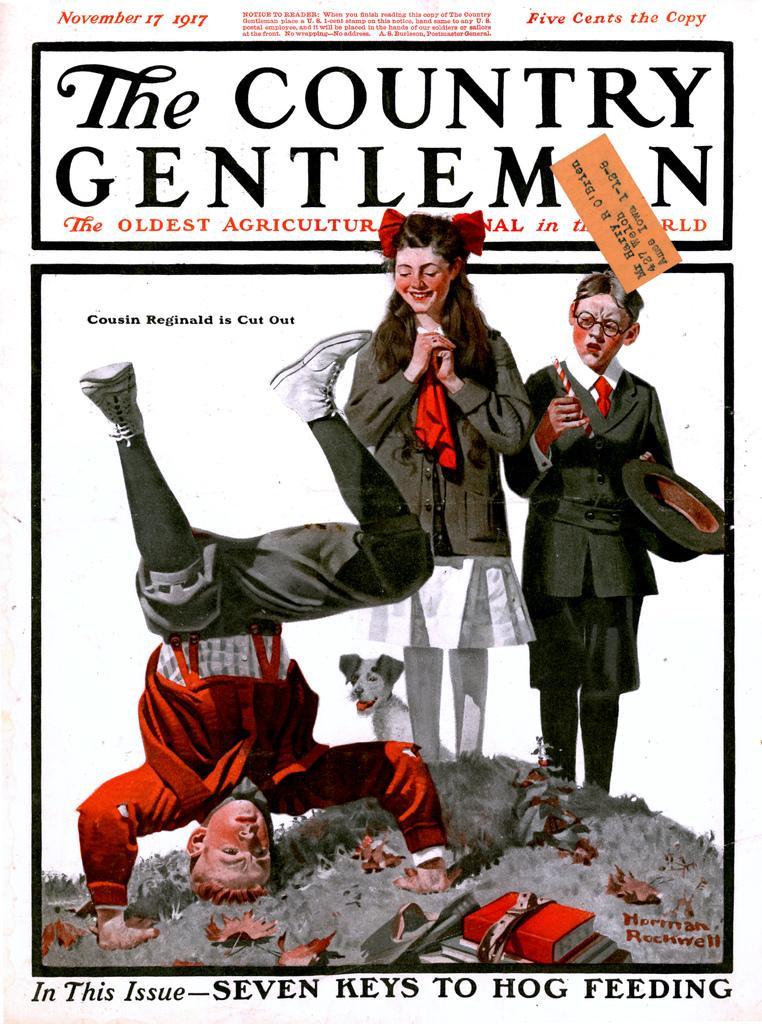Please provide a concise description of this image. In this picture I can see a poster, where I can see 2 boys, a girl and a dog and I can see the leaves and the books on the ground. I can also see something is written on the top and bottom sides of this picture. 